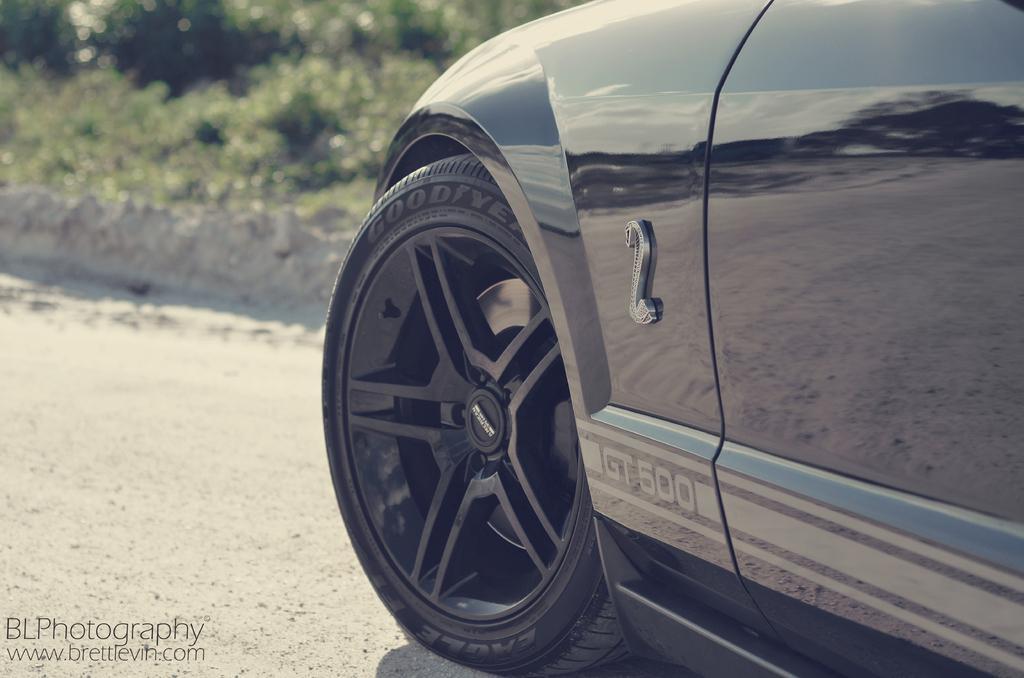Please provide a concise description of this image. In this picture we can see a car on the right side, in the background there are some plants, we can see some text at the left bottom. 